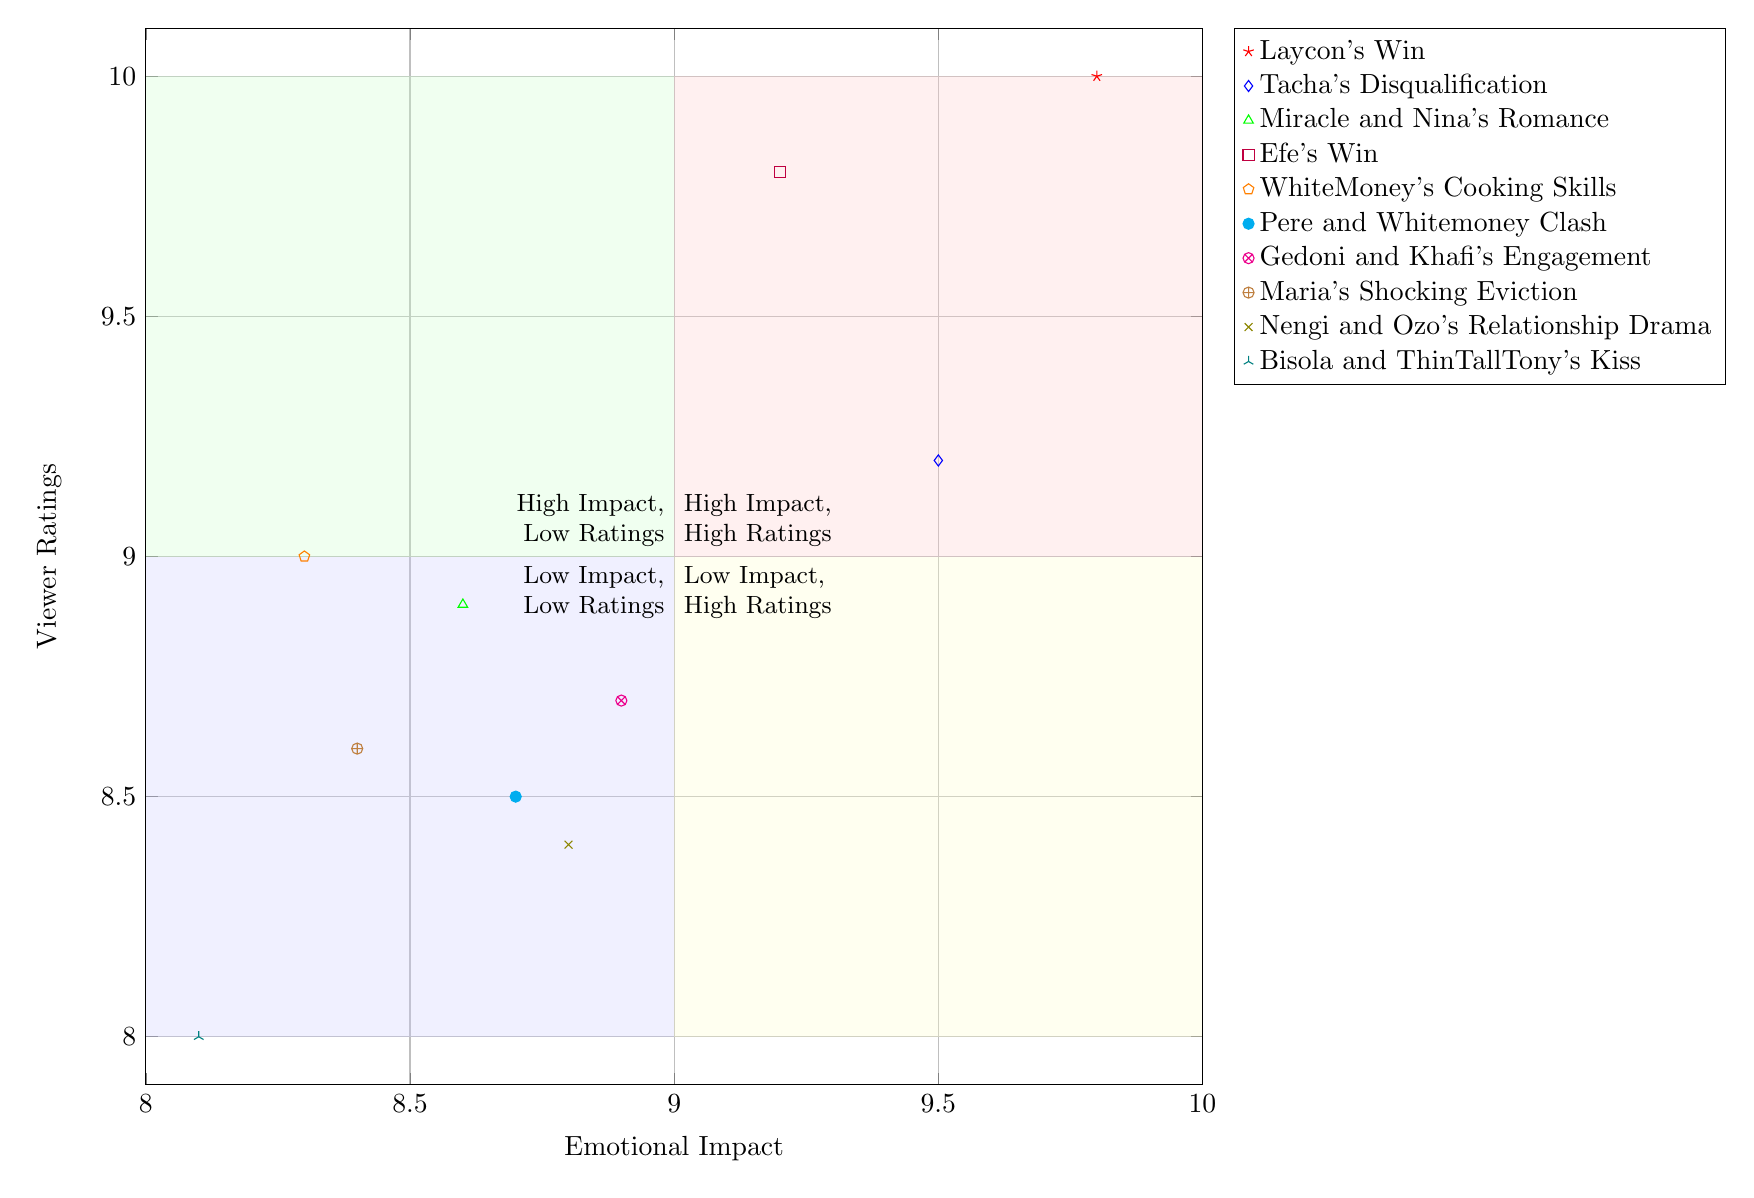What is the emotional impact score of Laycon's Win? The diagram places Laycon's Win at the coordinates (9.8, 10.0). The x-coordinate represents the emotional impact, which is 9.8.
Answer: 9.8 Which moment has the highest viewer rating? The viewer ratings are plotted along the y-axis. Looking at the points, Laycon's Win is at (9.8, 10.0), which is the highest y-coordinate among the all moments.
Answer: Laycon's Win What is the emotional impact score of Bisola and ThinTallTony's Kiss? The coordinates for Bisola and ThinTallTony's Kiss in the diagram are (8.1, 8.0). The emotional impact is found by looking at the x-coordinate, which is 8.1.
Answer: 8.1 How many moments have both high emotional impact and high viewer ratings? High emotional impact and high viewer ratings are represented in the first quadrant of the chart where both values are above 9. There are four moments in this quadrant: Laycon's Win, Tacha's Disqualification, Efe's Win and Miracle and Nina's Romance.
Answer: Four What is the lowest viewer rating among the listed moments? By scanning the y-coordinates of all the moments, Bisola and ThinTallTony's Kiss has the lowest viewer rating at the coordinate (8.1, 8.0), specifically the y-coordinate value of 8.0.
Answer: 8.0 Which moment has a high viewer rating but low emotional impact? To find this, look for points that have y-values above 9 but x-values below 9. The moment that falls into this category is WhiteMoney's Cooking Skills at (8.3, 9.0).
Answer: WhiteMoney's Cooking Skills What is the emotional impact of Tacha's Disqualification? Tacha's Disqualification is plotted at the coordinates (9.5, 9.2). The emotional impact is determined by the x-coordinate, which is 9.5.
Answer: 9.5 How many moments are plotted in the low emotional impact and low viewer ratings section? This section is found in the fourth quadrant where both values are low. Looking at the chart, there are no moments plotted in this quadrant.
Answer: Zero 